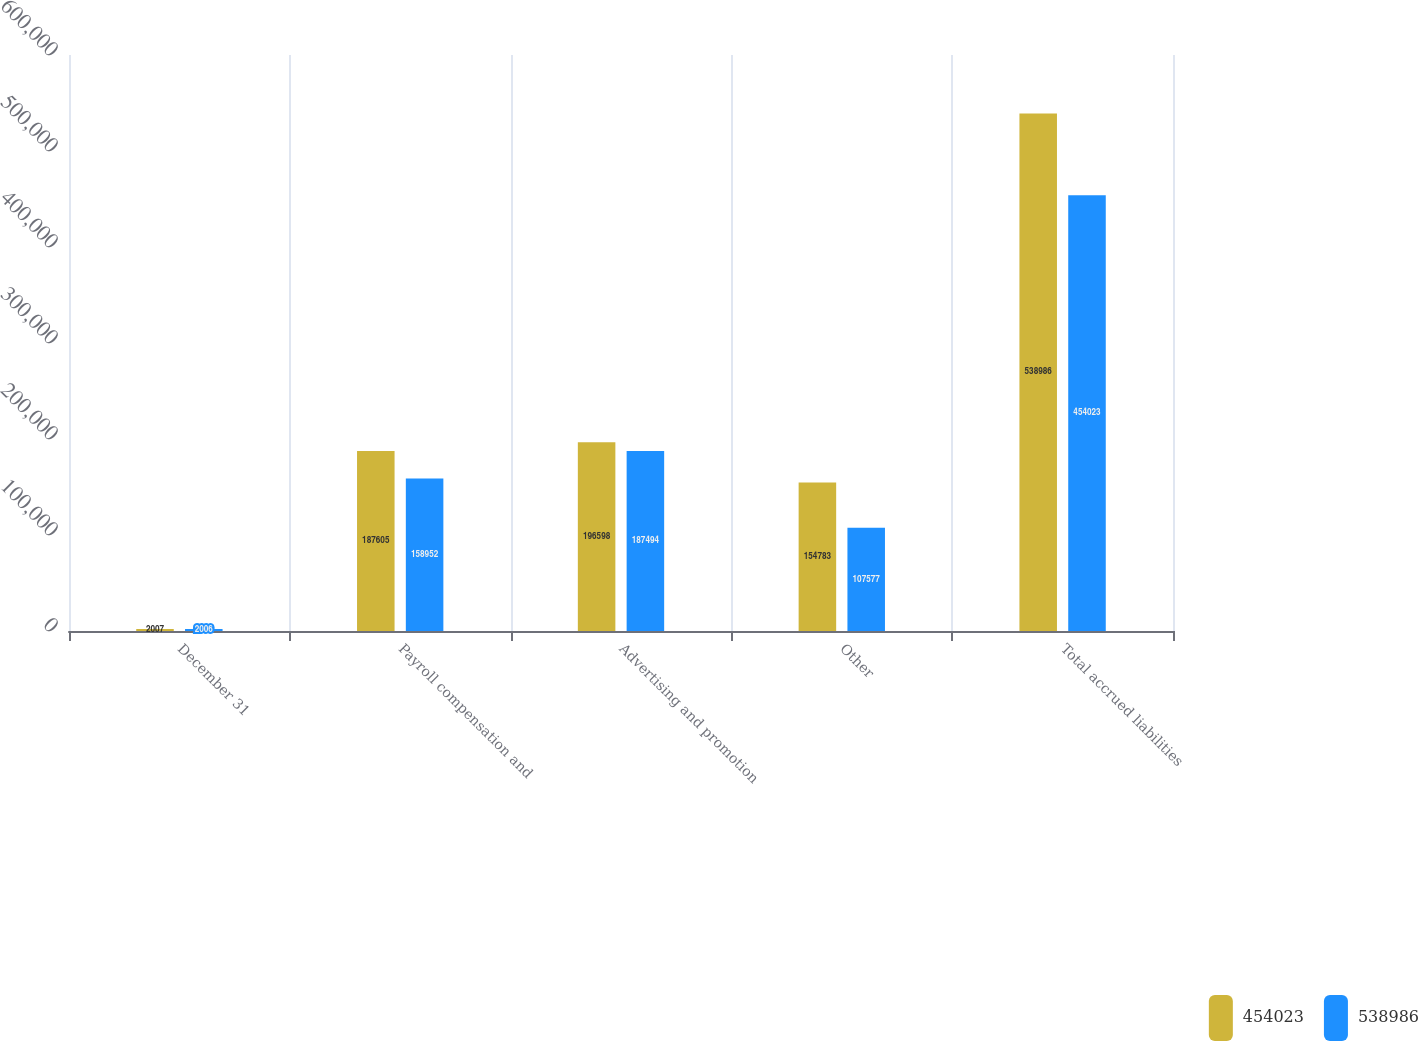Convert chart to OTSL. <chart><loc_0><loc_0><loc_500><loc_500><stacked_bar_chart><ecel><fcel>December 31<fcel>Payroll compensation and<fcel>Advertising and promotion<fcel>Other<fcel>Total accrued liabilities<nl><fcel>454023<fcel>2007<fcel>187605<fcel>196598<fcel>154783<fcel>538986<nl><fcel>538986<fcel>2006<fcel>158952<fcel>187494<fcel>107577<fcel>454023<nl></chart> 